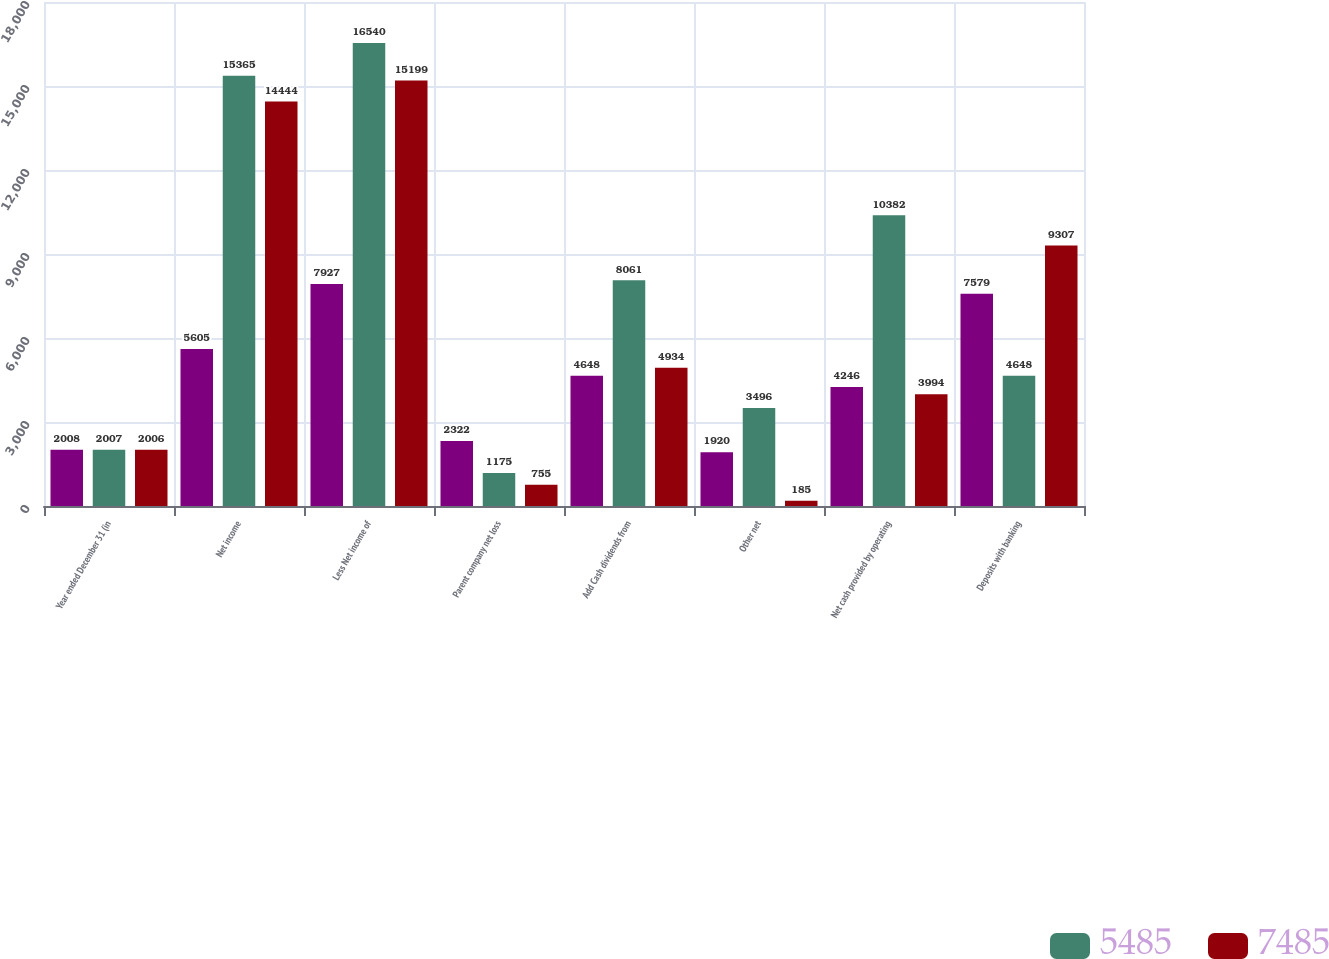Convert chart. <chart><loc_0><loc_0><loc_500><loc_500><stacked_bar_chart><ecel><fcel>Year ended December 31 (in<fcel>Net income<fcel>Less Net income of<fcel>Parent company net loss<fcel>Add Cash dividends from<fcel>Other net<fcel>Net cash provided by operating<fcel>Deposits with banking<nl><fcel>nan<fcel>2008<fcel>5605<fcel>7927<fcel>2322<fcel>4648<fcel>1920<fcel>4246<fcel>7579<nl><fcel>5485<fcel>2007<fcel>15365<fcel>16540<fcel>1175<fcel>8061<fcel>3496<fcel>10382<fcel>4648<nl><fcel>7485<fcel>2006<fcel>14444<fcel>15199<fcel>755<fcel>4934<fcel>185<fcel>3994<fcel>9307<nl></chart> 